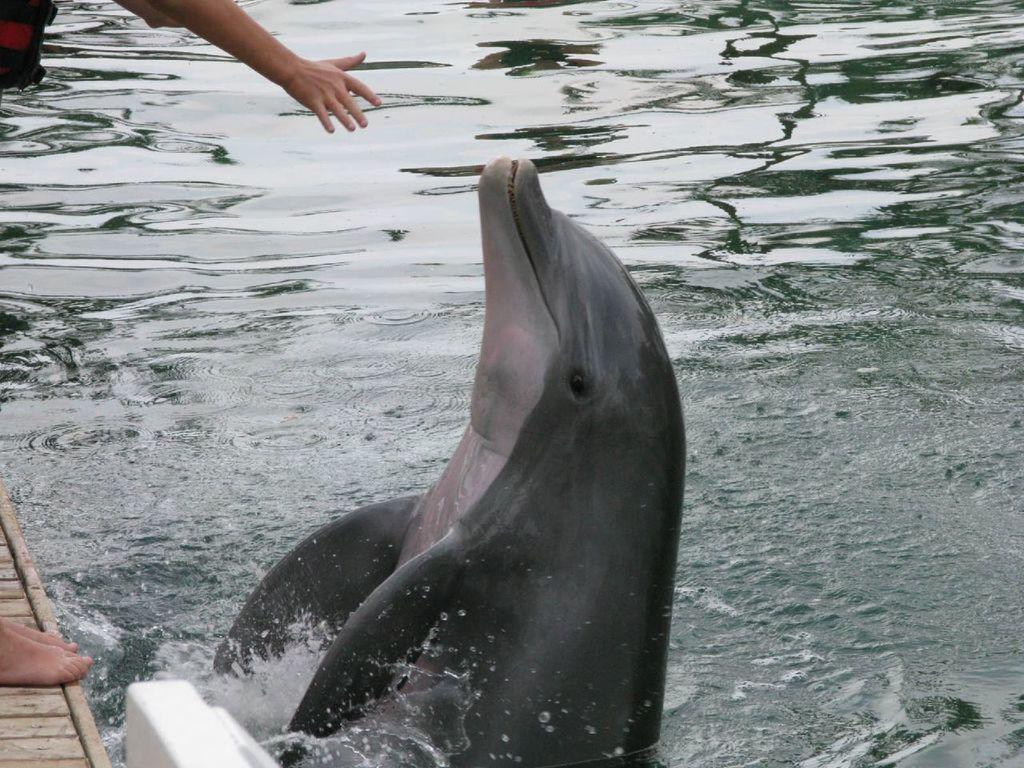What animal can be seen in the water in the image? There is a dolphin in the water in the image. What is the position of the person in the image? There is a person standing on the ground to the left in the image. What is the primary element visible in the image? Water is visible in the image. What type of pies can be seen on the table in the image? There is no table or pies present in the image; it features a dolphin in the water and a person standing on the ground. 